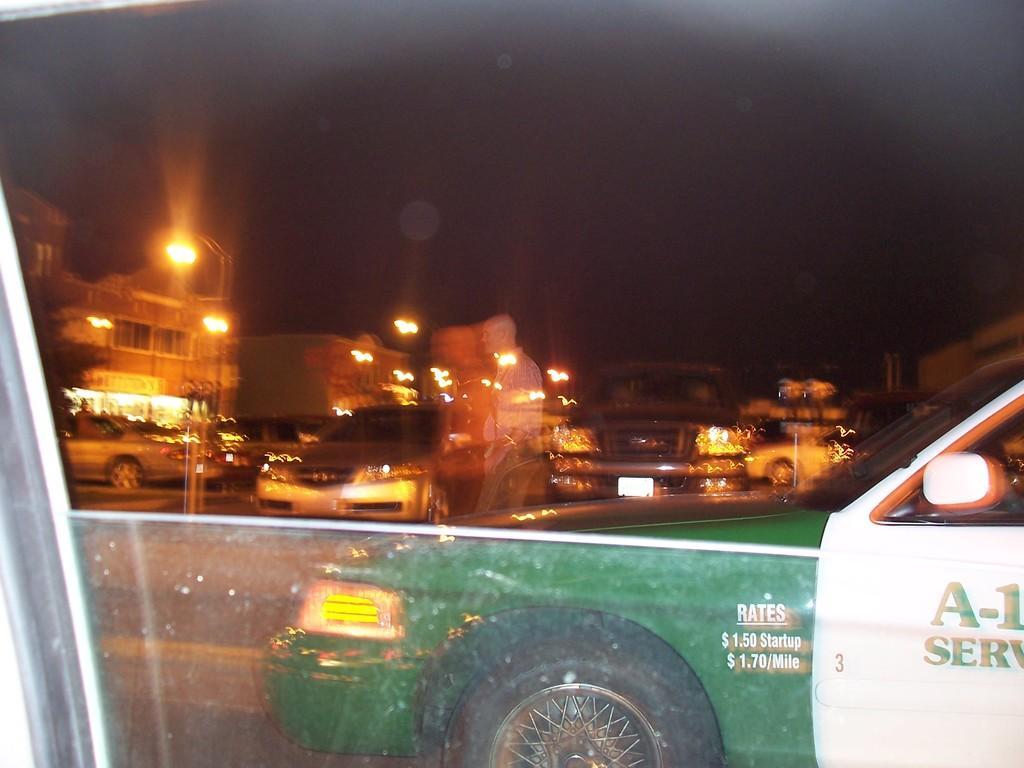Could you give a brief overview of what you see in this image? In the foreground of this image, through the window of a vehicle, there is a car moving on the road, a man, few vehicles, poles, lights, buildings and the dark sky in the background. 